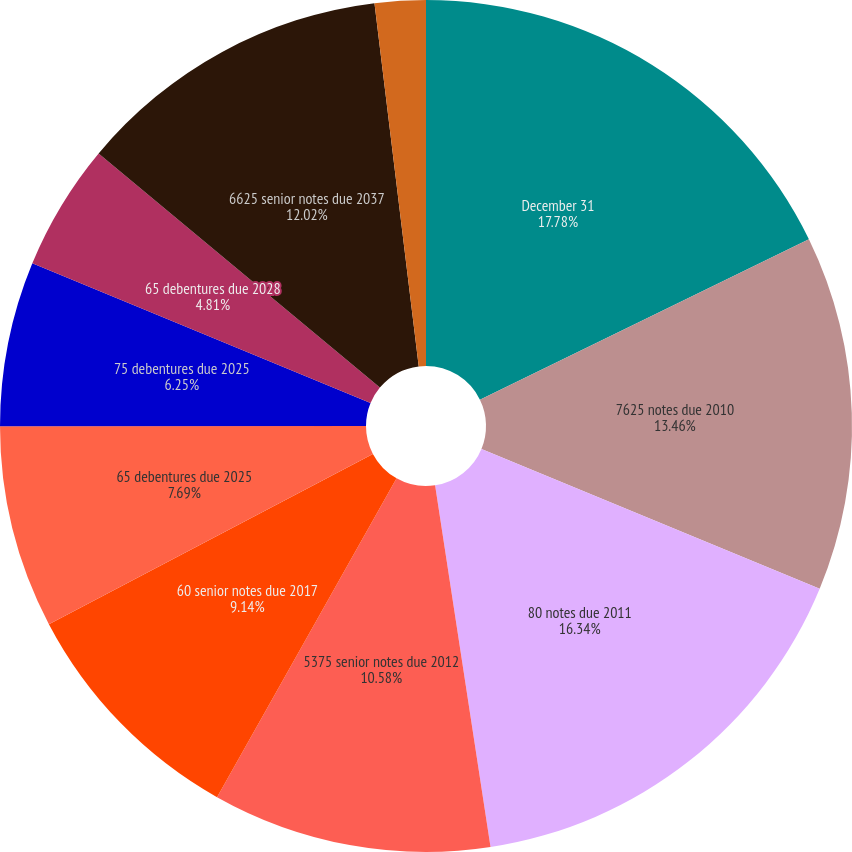Convert chart. <chart><loc_0><loc_0><loc_500><loc_500><pie_chart><fcel>December 31<fcel>7625 notes due 2010<fcel>80 notes due 2011<fcel>5375 senior notes due 2012<fcel>60 senior notes due 2017<fcel>65 debentures due 2025<fcel>75 debentures due 2025<fcel>65 debentures due 2028<fcel>6625 senior notes due 2037<fcel>522 debentures due 2097<nl><fcel>17.78%<fcel>13.46%<fcel>16.34%<fcel>10.58%<fcel>9.14%<fcel>7.69%<fcel>6.25%<fcel>4.81%<fcel>12.02%<fcel>1.93%<nl></chart> 